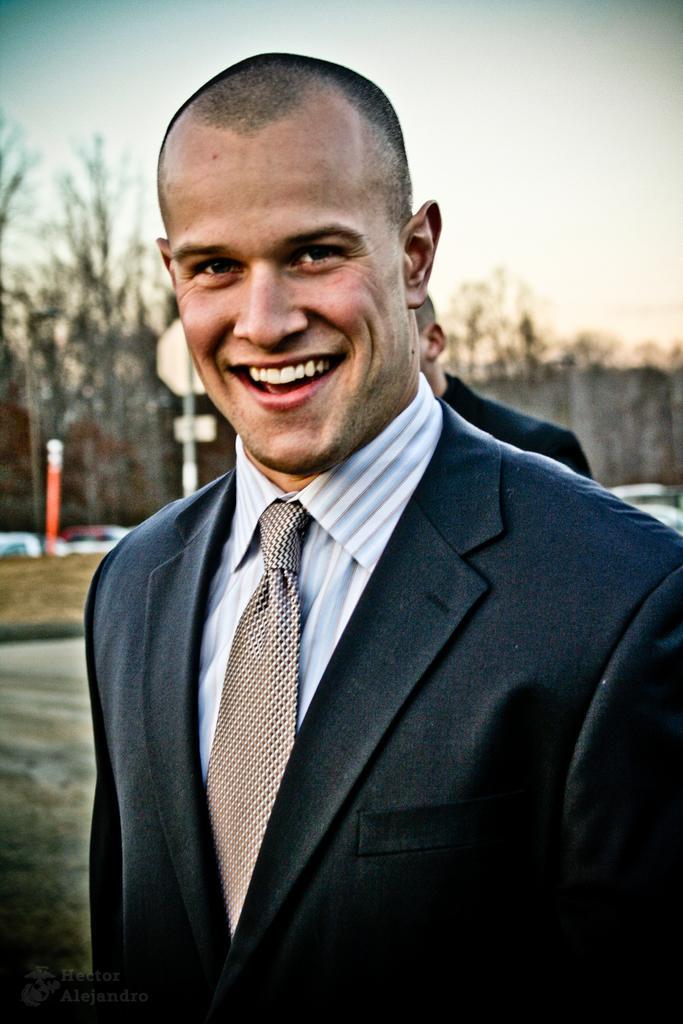In one or two sentences, can you explain what this image depicts? In the picture I can see a person wearing blazer, shirt and tie is standing and smiling. In the background, we can see another person, we can see boards, trees and the sky. 